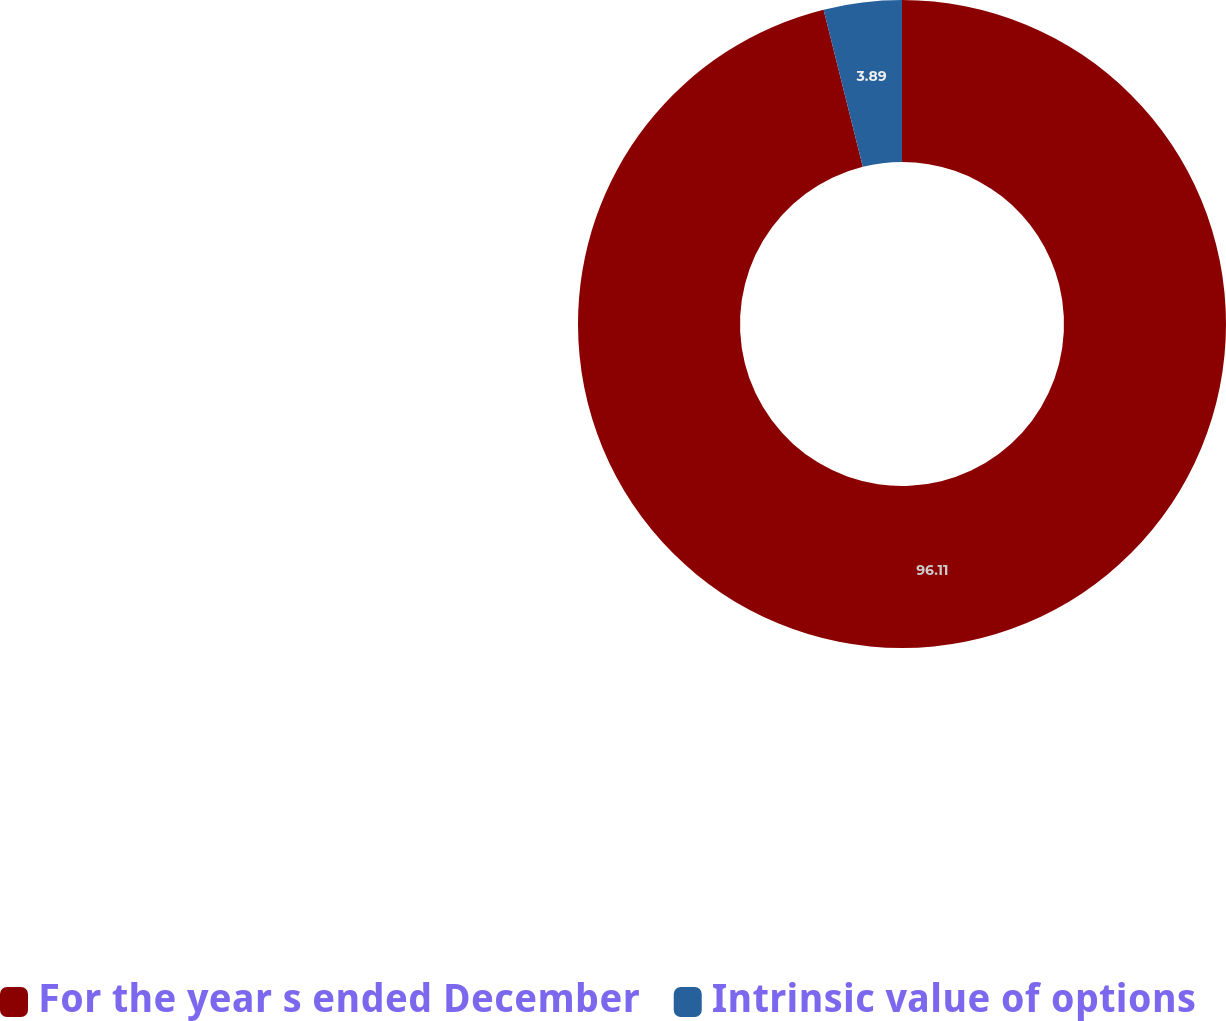<chart> <loc_0><loc_0><loc_500><loc_500><pie_chart><fcel>For the year s ended December<fcel>Intrinsic value of options<nl><fcel>96.11%<fcel>3.89%<nl></chart> 